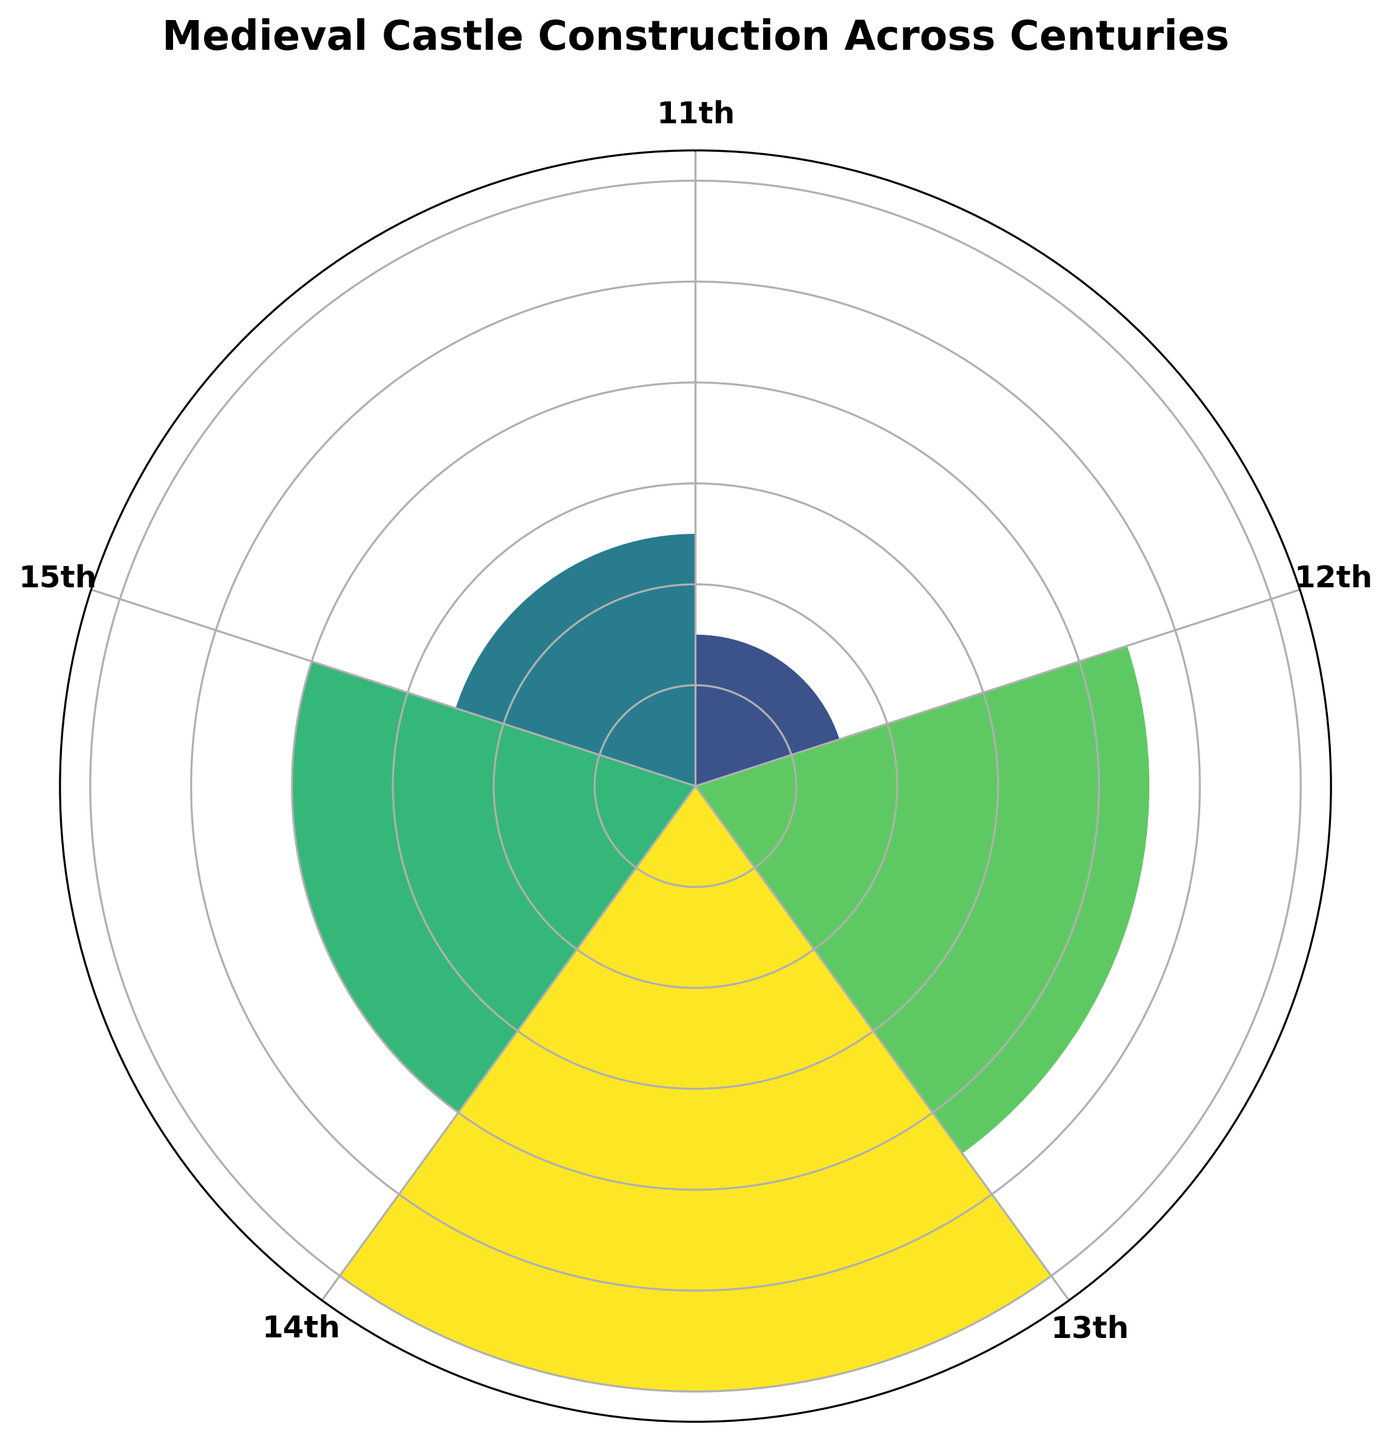What's the century with the highest number of castle constructions? The rose chart shows concentric bars labeled by centuries. The tallest bar represents the highest count, which visually correlates with the 13th century.
Answer: 13th Which century saw a decrease in castle constructions compared to the previous century? Comparing the length of bars from one century to the next, the 14th-century bar is shorter than the 13th-century bar, indicating a decrease.
Answer: 14th What's the difference in castle constructions between the 12th and 15th centuries? According to the chart, the bar for the 12th century shows 45 constructions, and the 15th century shows 25. The difference is 45 - 25.
Answer: 20 Which two centuries have the closest number of castle constructions? By comparing the heights of the bars, the 11th century with 15 and the 15th century with 25 are closer to each other compared to other pairs.
Answer: 11th and 15th What is the sum of castle constructions for the 13th and 14th centuries combined? The chart shows 60 castles constructed in the 13th century and 40 in the 14th century. Adding these together gives 60 + 40.
Answer: 100 How does the 12th century's castle construction count compare to the 11th century? The bar for the 12th century is significantly higher than that for the 11th century. Therefore, the 12th century has a greater number of constructions.
Answer: Greater Is the count of castle constructions in the 15th century half of those in the 13th century? The bar for the 13th century indicates 60 constructions, and half of 60 is 30. The bar for the 15th century shows 25 constructions, which is less than half of 60.
Answer: No Which century's bar lies exactly at the bottom of the chart? In a polar rose chart, the position at the bottom relates to the starting century, which is the 11th century.
Answer: 11th What is the average number of castle constructions across all centuries shown? The counts are 15, 45, 60, 40, and 25. The average is calculated as (15 + 45 + 60 + 40 + 25) / 5.
Answer: 37 What color represents the century with the most constructions? The bar with the most constructions (13th century) is shaded the deepest color as per the color gradient, which is typically the darkest hue in the rose chart.
Answer: Darkest hue (usually dark green or blue) 